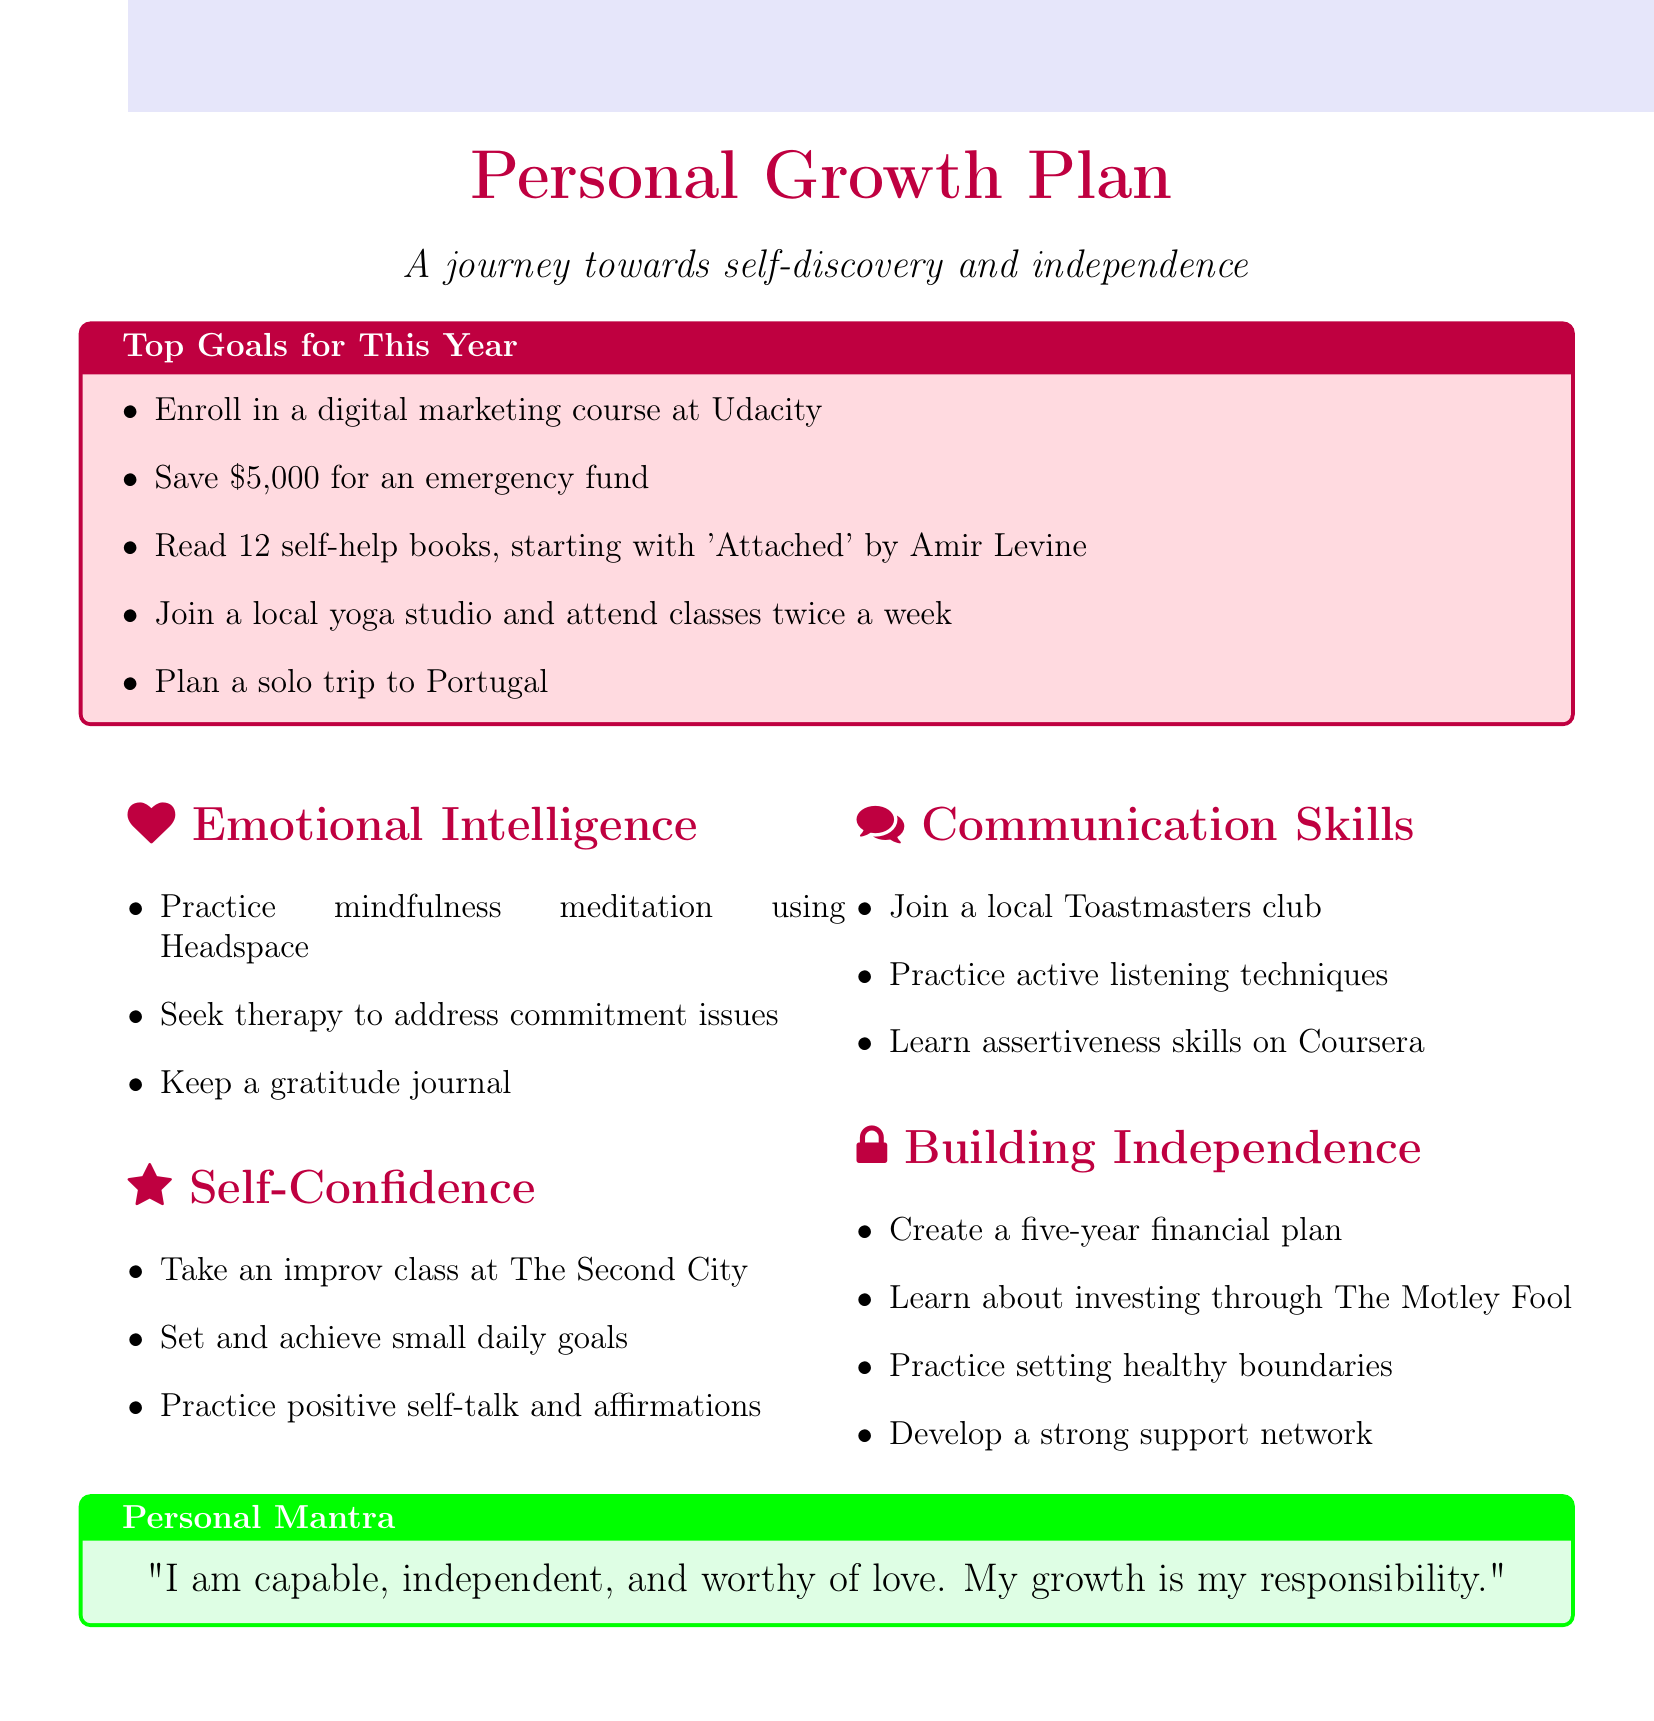what is the first course listed under Career goals? The Career goals list includes three goals, and the first one is to enroll in a course.
Answer: digital marketing course at Udacity how much money does the Finance goal aim to save? The Finance goals include three financial objectives, one of which is saving a specific amount of money.
Answer: $5,000 which book is suggested to start reading under Personal Development? Within the Personal Development goals, one goal is reading a specific book.
Answer: 'Attached' by Amir Levine how many self-help books are planned to be read this year? The Personal Development goals specify the total number of self-help books to be read.
Answer: 12 what two activities are emphasized under Emotional Independence? The independence building strategies list actions for emotional independence.
Answer: Practice setting and maintaining healthy boundaries in relationships, develop a strong support network outside of romantic relationships which skill should be improved by joining Toastmasters? One of the activities listed under Communication Skills focuses on joining a specific club.
Answer: public speaking what is the personal mantra stated in the document? The document includes a personal mantra in a highlighted box.
Answer: "I am capable, independent, and worthy of love. My growth is my responsibility." how many networking events are planned to attend in the tech industry? The Career goals mention a specific number of events to attend for networking purposes.
Answer: three which app is recommended for budgeting? The Finance goals identify a specific app for creating a budget.
Answer: YNAB (You Need A Budget) app 